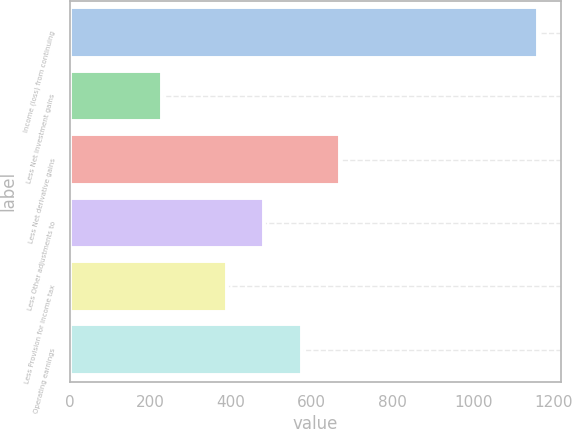<chart> <loc_0><loc_0><loc_500><loc_500><bar_chart><fcel>Income (loss) from continuing<fcel>Less Net investment gains<fcel>Less Net derivative gains<fcel>Less Other adjustments to<fcel>Less Provision for income tax<fcel>Operating earnings<nl><fcel>1160<fcel>228<fcel>668.6<fcel>482.2<fcel>389<fcel>575.4<nl></chart> 